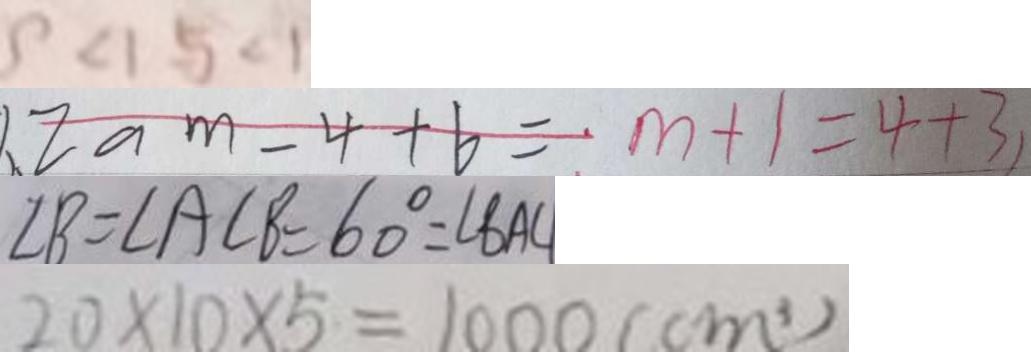<formula> <loc_0><loc_0><loc_500><loc_500>9 < 1 5 < 1 
 1 . 2 a m - 4 + 6 = m + 1 = 4 + 3 
 \angle B = \angle A C B = 6 0 ^ { \circ } = \angle B A C 
 2 0 \times 1 0 \times 5 = 1 0 0 0 ( c m ^ { 3 } )</formula> 